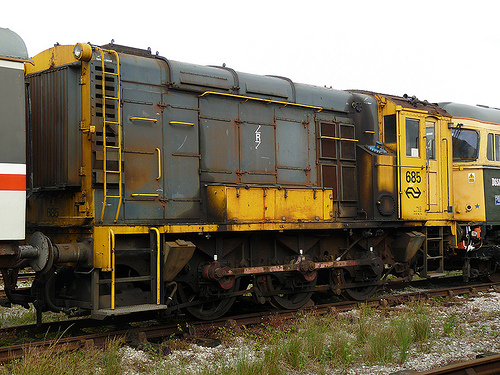Are there both windows and cars in this image? Yes, the image features both windows and train cars. 